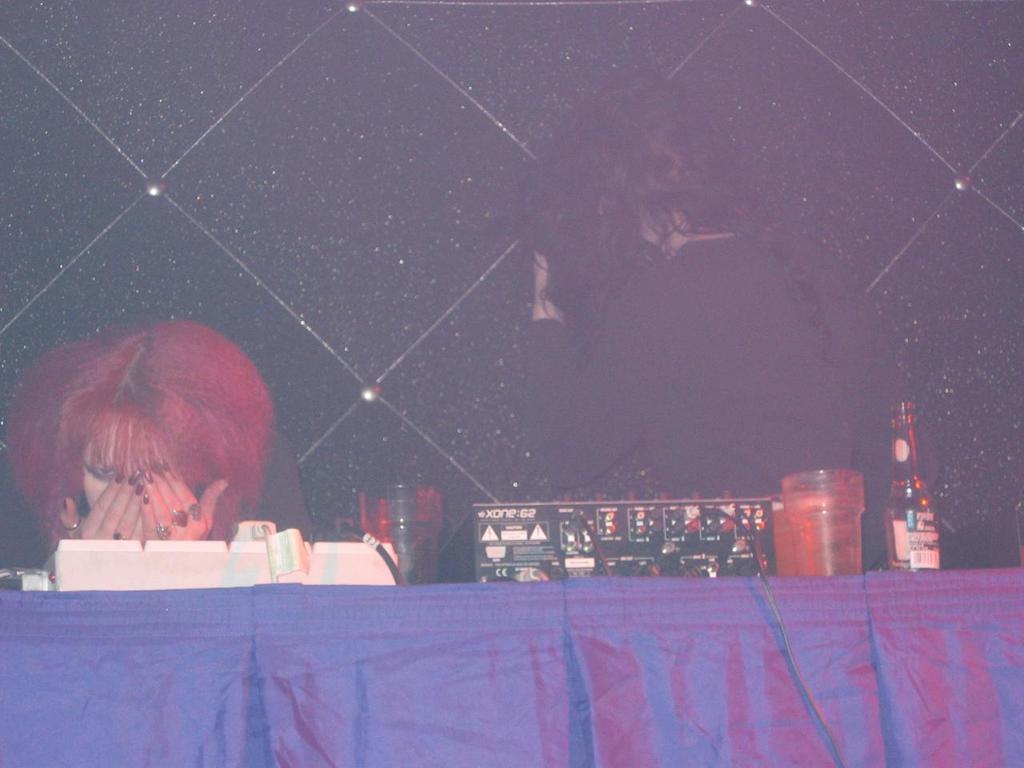In one or two sentences, can you explain what this image depicts? At the bottom of the image there is a table with glasses, bottles, white and black boxes. There are wires and buttons on the box. Behind the table there are two ladies. In the background there is a black curtain with a design on it.  